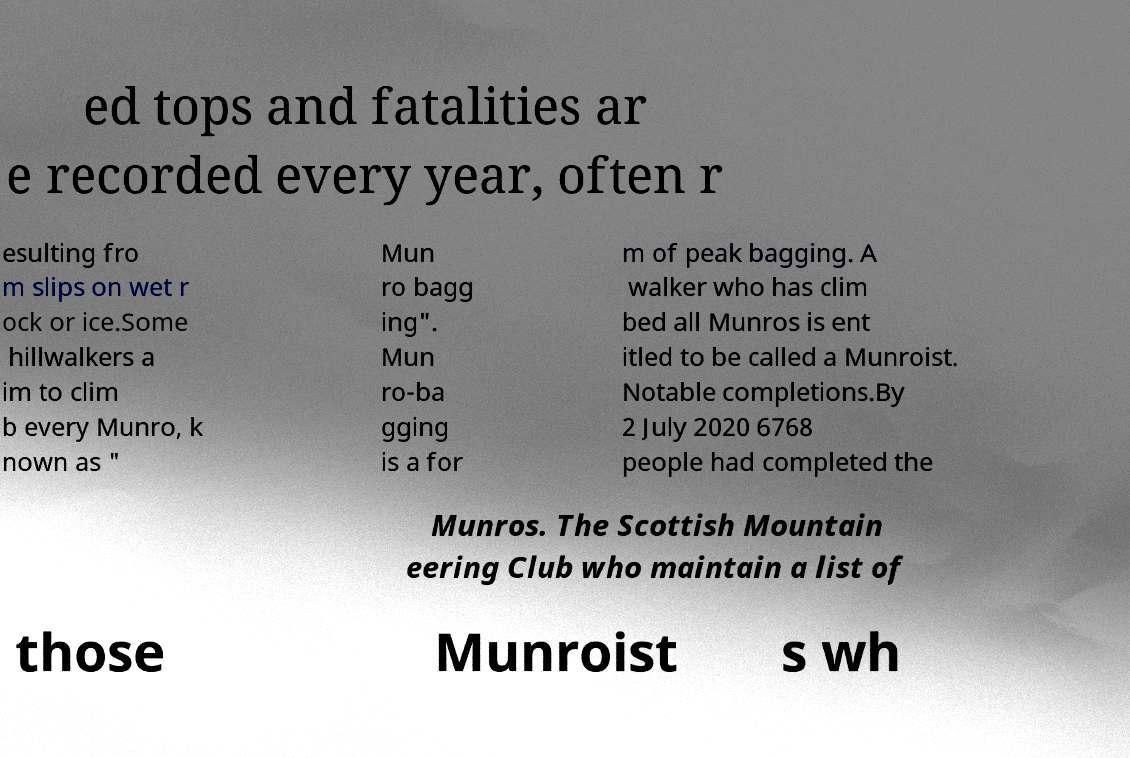Please read and relay the text visible in this image. What does it say? ed tops and fatalities ar e recorded every year, often r esulting fro m slips on wet r ock or ice.Some hillwalkers a im to clim b every Munro, k nown as " Mun ro bagg ing". Mun ro-ba gging is a for m of peak bagging. A walker who has clim bed all Munros is ent itled to be called a Munroist. Notable completions.By 2 July 2020 6768 people had completed the Munros. The Scottish Mountain eering Club who maintain a list of those Munroist s wh 